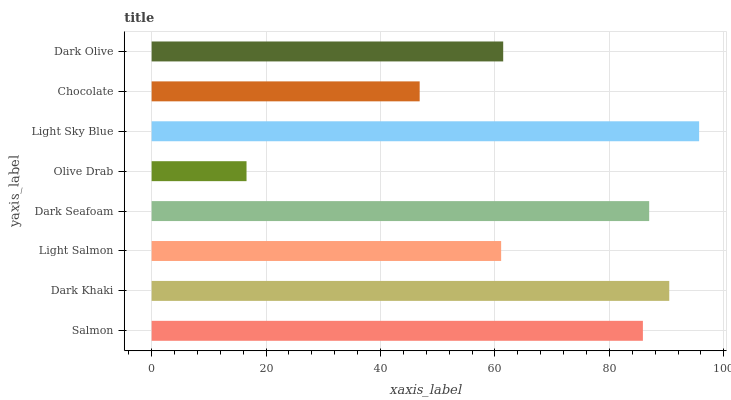Is Olive Drab the minimum?
Answer yes or no. Yes. Is Light Sky Blue the maximum?
Answer yes or no. Yes. Is Dark Khaki the minimum?
Answer yes or no. No. Is Dark Khaki the maximum?
Answer yes or no. No. Is Dark Khaki greater than Salmon?
Answer yes or no. Yes. Is Salmon less than Dark Khaki?
Answer yes or no. Yes. Is Salmon greater than Dark Khaki?
Answer yes or no. No. Is Dark Khaki less than Salmon?
Answer yes or no. No. Is Salmon the high median?
Answer yes or no. Yes. Is Dark Olive the low median?
Answer yes or no. Yes. Is Light Salmon the high median?
Answer yes or no. No. Is Light Sky Blue the low median?
Answer yes or no. No. 